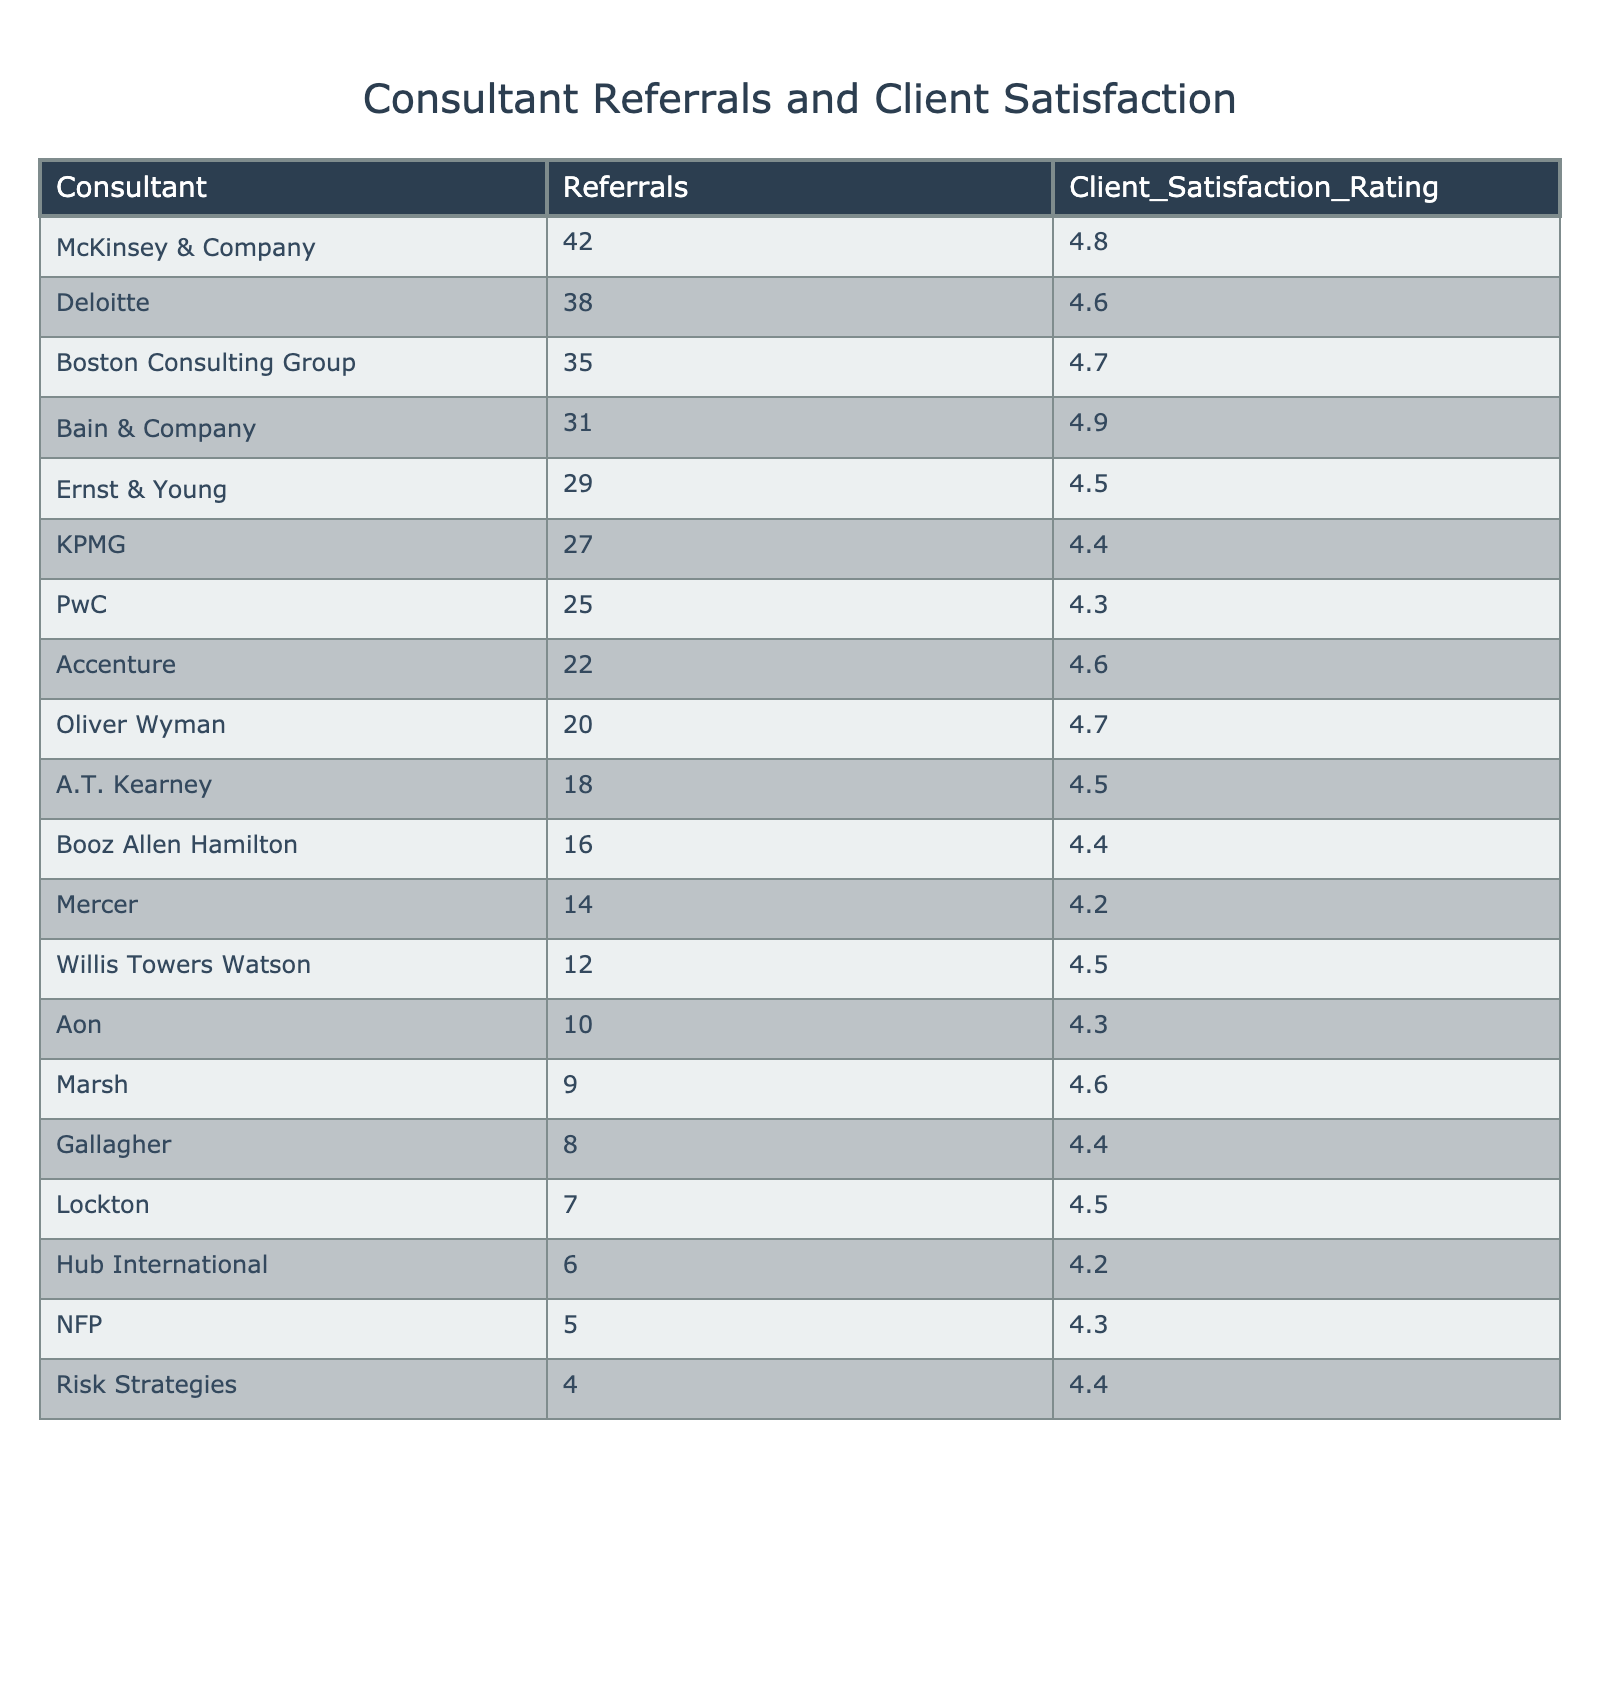What is the client satisfaction rating for McKinsey & Company? The client satisfaction rating for McKinsey & Company is listed in the table under the "Client_Satisfaction_Rating" column, where it shows 4.8.
Answer: 4.8 Which consultant received the highest number of referrals? Referrals can be compared by looking at the "Referrals" column, where McKinsey & Company has the highest value at 42.
Answer: McKinsey & Company What is the average client satisfaction rating for the top three consultants by referrals? The top three consultants by referrals are McKinsey & Company (4.8), Deloitte (4.6), and Boston Consulting Group (4.7). Their ratings are added: 4.8 + 4.6 + 4.7 = 14.1, and then divided by 3 results in an average rating of 4.7.
Answer: 4.7 Is it true that Deloitte has a higher client satisfaction rating than KPMG? By comparing the "Client_Satisfaction_Rating" values for Deloitte (4.6) and KPMG (4.4), Deloitte has a higher rating.
Answer: Yes Which consultant has the lowest client satisfaction rating, and what is that rating? The lowest client satisfaction rating can be found under the "Client_Satisfaction_Rating" column, where Mercer has the lowest value of 4.2.
Answer: Mercer, 4.2 How many total referrals did the top five consultants receive? The referrals for the top five consultants (McKinsey & Company, Deloitte, Boston Consulting Group, Bain & Company, and Ernst & Young) are summed: 42 + 38 + 35 + 31 + 29 = 205.
Answer: 205 What is the difference between the client satisfaction ratings of the top consultant and the bottom consultant? The top consultant (McKinsey & Company) has a rating of 4.8 and the bottom consultant (Mercer) has a rating of 4.2. The difference is 4.8 - 4.2 = 0.6.
Answer: 0.6 Which consultant has a client satisfaction rating of 4.5? The table lists multiple consultants with a rating of 4.5, including Bain & Company, A.T. Kearney, and Willis Towers Watson.
Answer: Bain & Company, A.T. Kearney, Willis Towers Watson What is the total number of referrals for consultants with a client satisfaction rating of 4.4 or lower? Consultants with a rating of 4.4 or lower are KPMG (27), PwC (25), Booz Allen Hamilton (16), Mercer (14), Aon (10), and Gallagher (8). Their total referrals are 27 + 25 + 16 + 14 + 10 + 8 = 100.
Answer: 100 What percentage of the total referrals were for the top consultant? The total number of referrals from all consultants is 42 + 38 + 35 + 31 + 29 + 27 + 25 + 22 + 20 + 18 + 16 + 14 + 12 + 10 + 9 + 8 + 7 + 6 + 5 + 4 = 405. McKinsey & Company has 42 referrals. The percentage is (42 / 405) * 100 = 10.37%.
Answer: 10.37% 